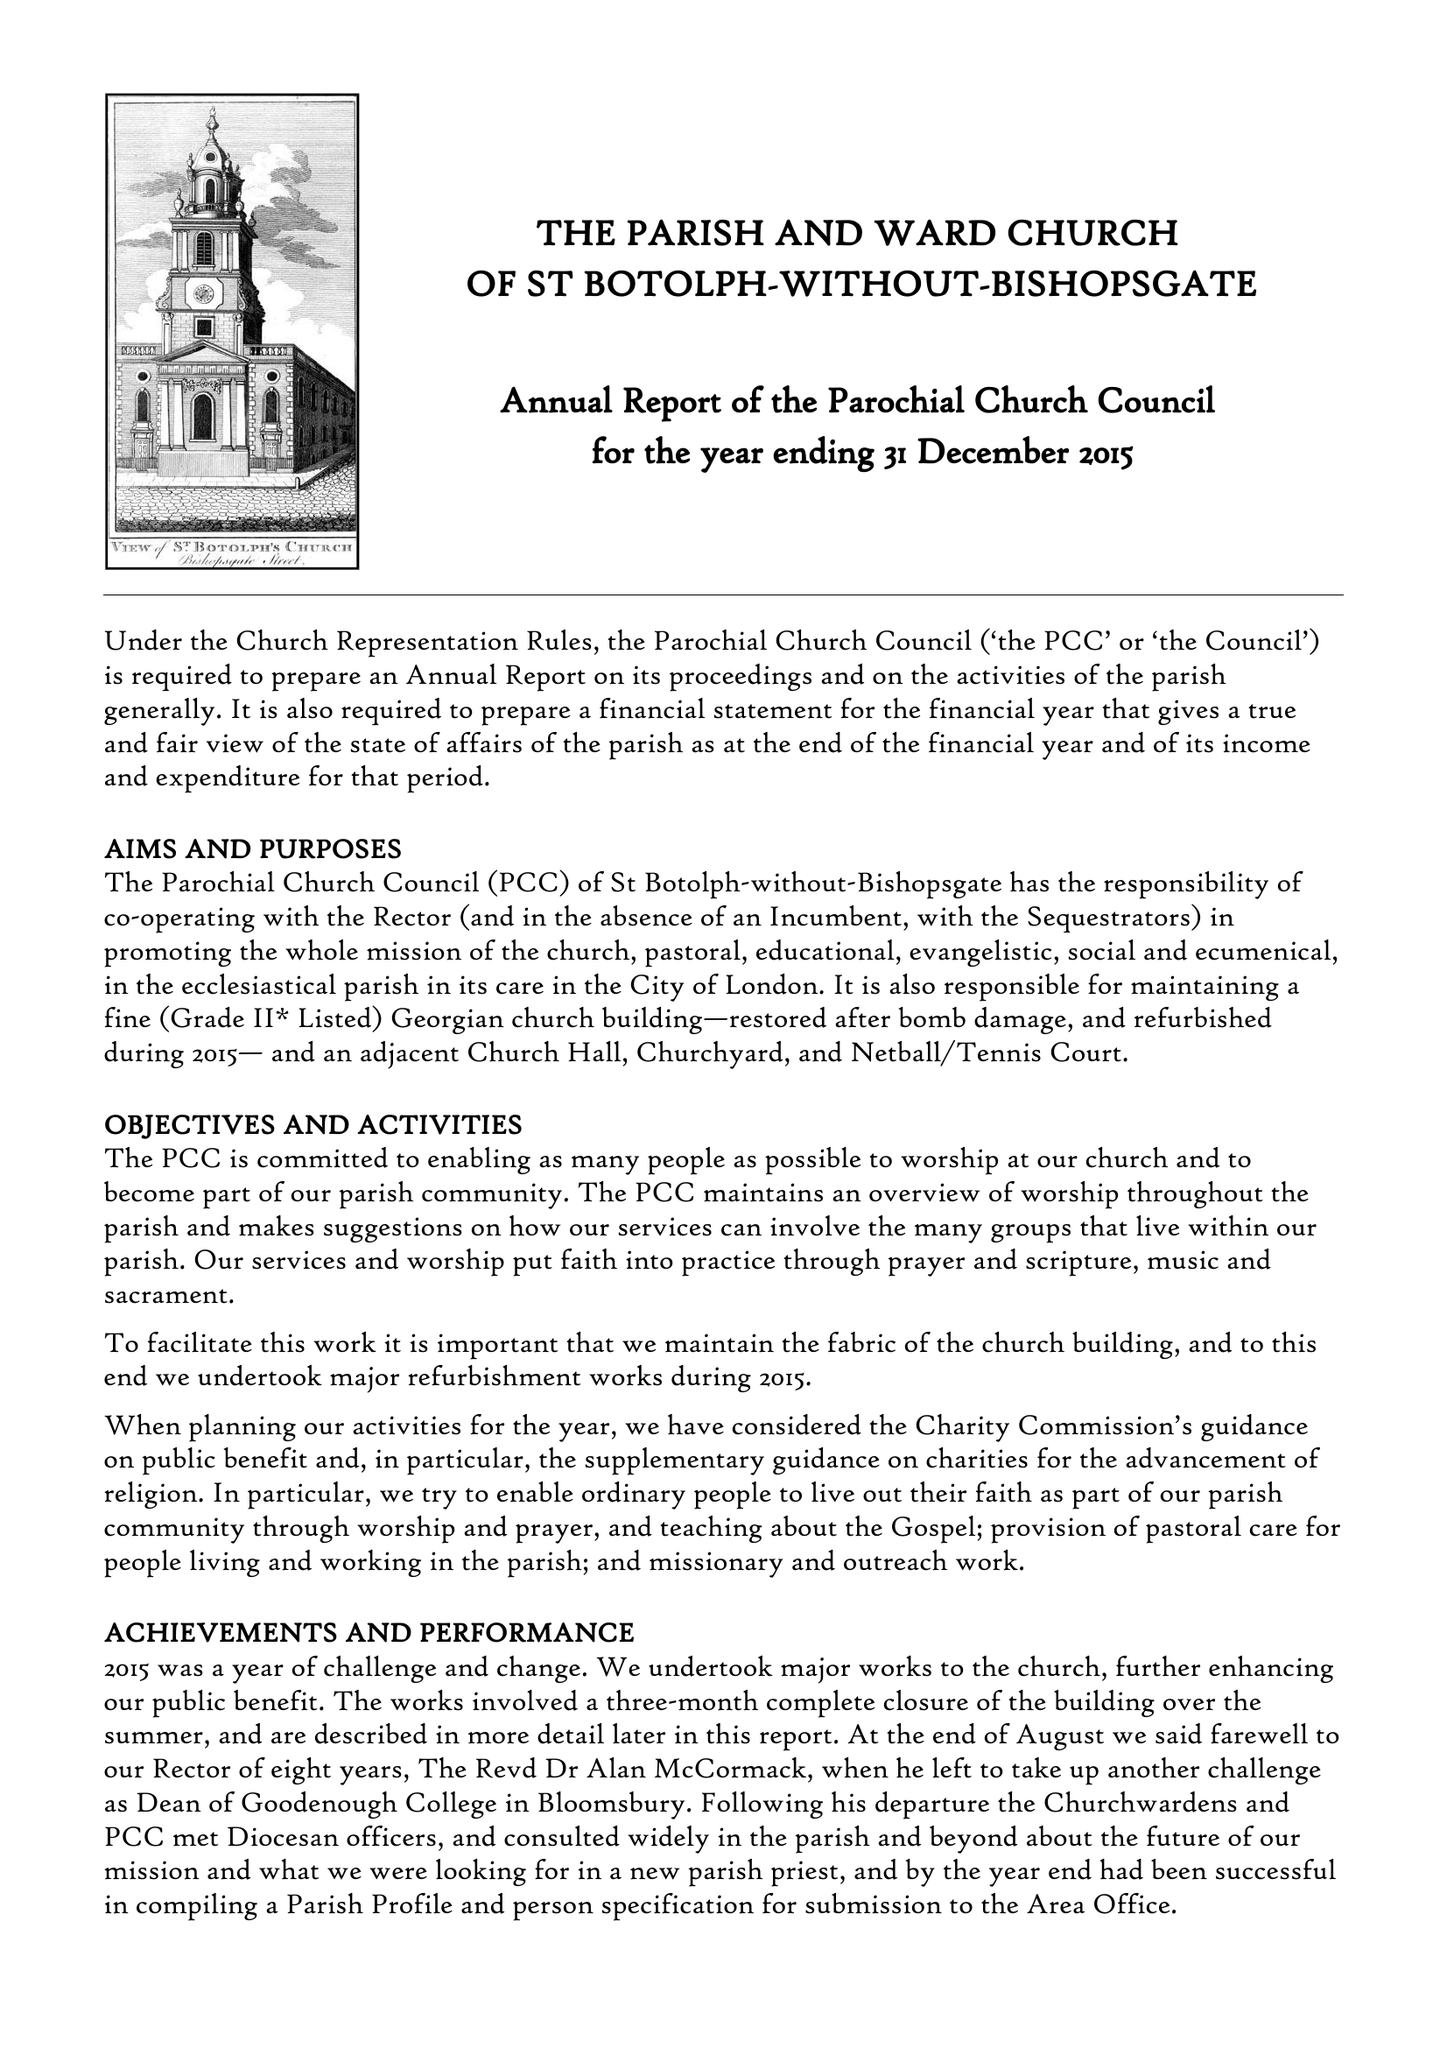What is the value for the address__street_line?
Answer the question using a single word or phrase. BISHOPSGATE 